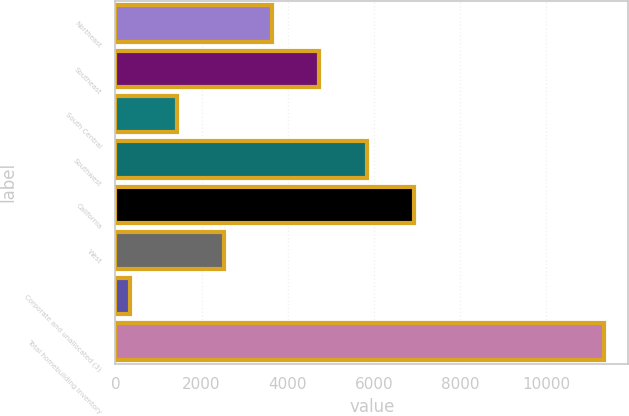<chart> <loc_0><loc_0><loc_500><loc_500><bar_chart><fcel>Northeast<fcel>Southeast<fcel>South Central<fcel>Southwest<fcel>California<fcel>West<fcel>Corporate and unallocated (3)<fcel>Total homebuilding inventory<nl><fcel>3631.9<fcel>4733.5<fcel>1428.7<fcel>5835.1<fcel>6936.7<fcel>2530.3<fcel>327.1<fcel>11343.1<nl></chart> 